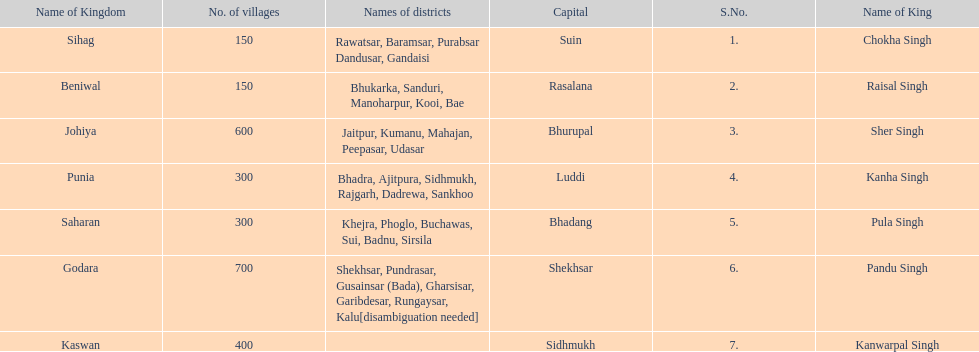He was the king of the sihag kingdom. Chokha Singh. 